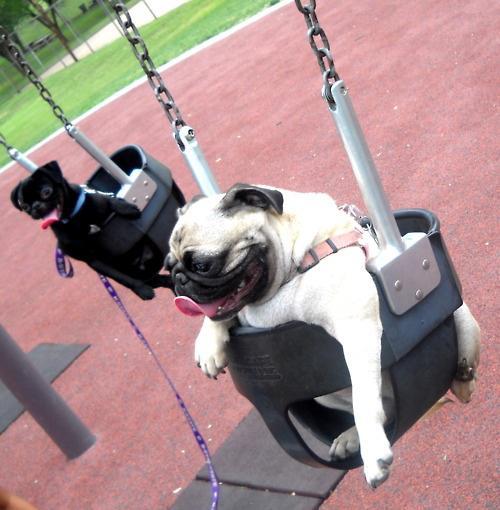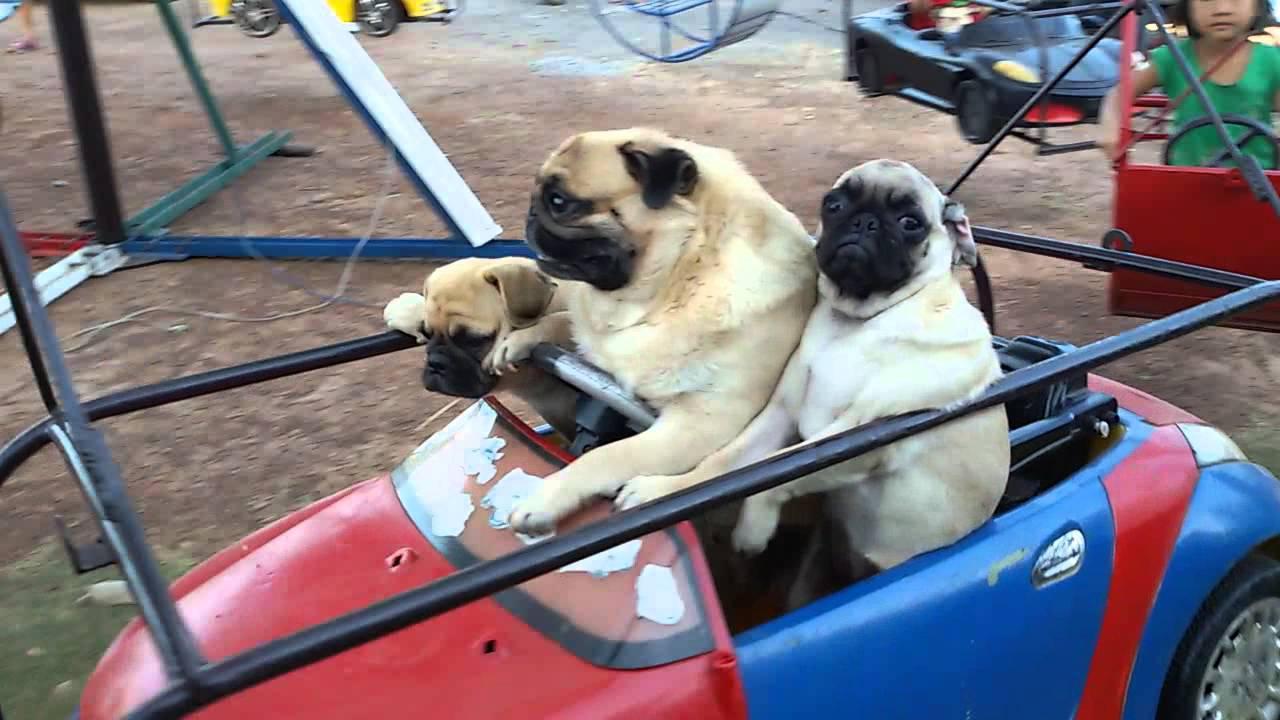The first image is the image on the left, the second image is the image on the right. For the images displayed, is the sentence "Three beige pugs with dark muzzles are sitting in a row inside a red and blue car, and the middle dog has one paw on the steering wheel." factually correct? Answer yes or no. Yes. The first image is the image on the left, the second image is the image on the right. For the images displayed, is the sentence "Some dogs are riding a carnival ride." factually correct? Answer yes or no. Yes. 